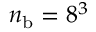Convert formula to latex. <formula><loc_0><loc_0><loc_500><loc_500>n _ { b } = 8 ^ { 3 }</formula> 